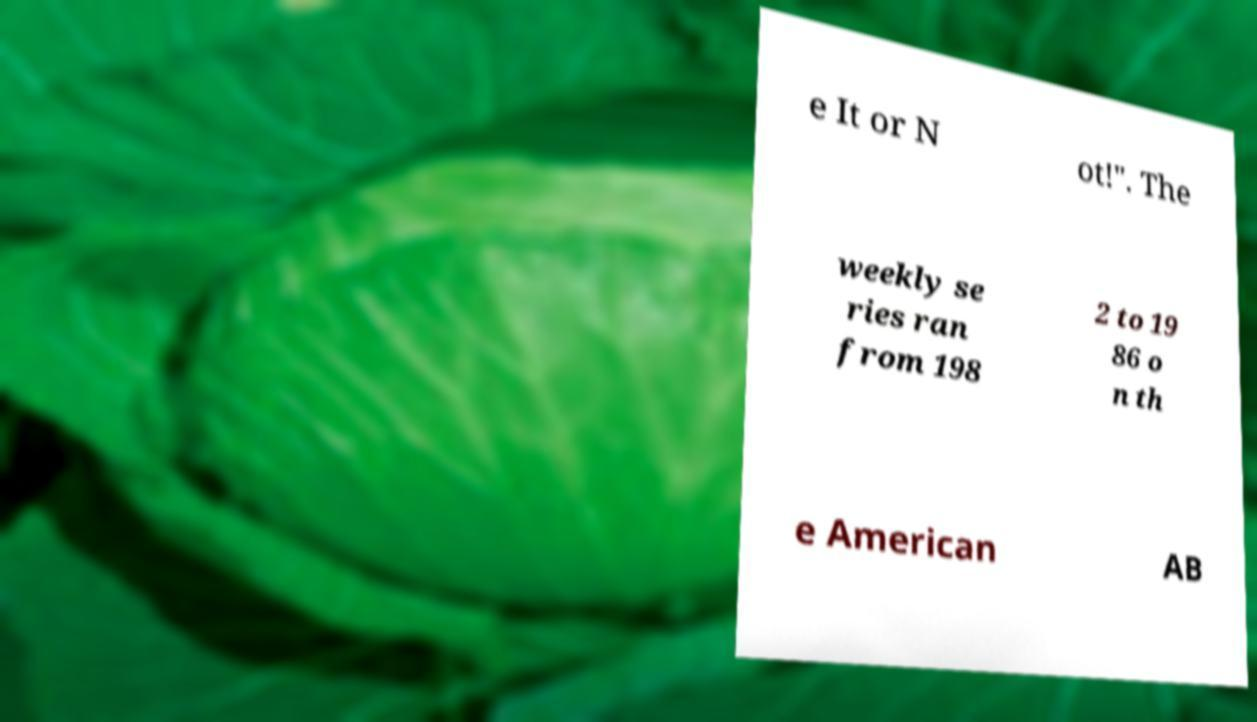For documentation purposes, I need the text within this image transcribed. Could you provide that? e It or N ot!". The weekly se ries ran from 198 2 to 19 86 o n th e American AB 